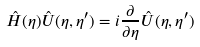<formula> <loc_0><loc_0><loc_500><loc_500>\hat { H } ( \eta ) \hat { U } ( \eta , \eta ^ { \prime } ) = i \frac { \partial } { \partial \eta } \hat { U } ( \eta , \eta ^ { \prime } )</formula> 